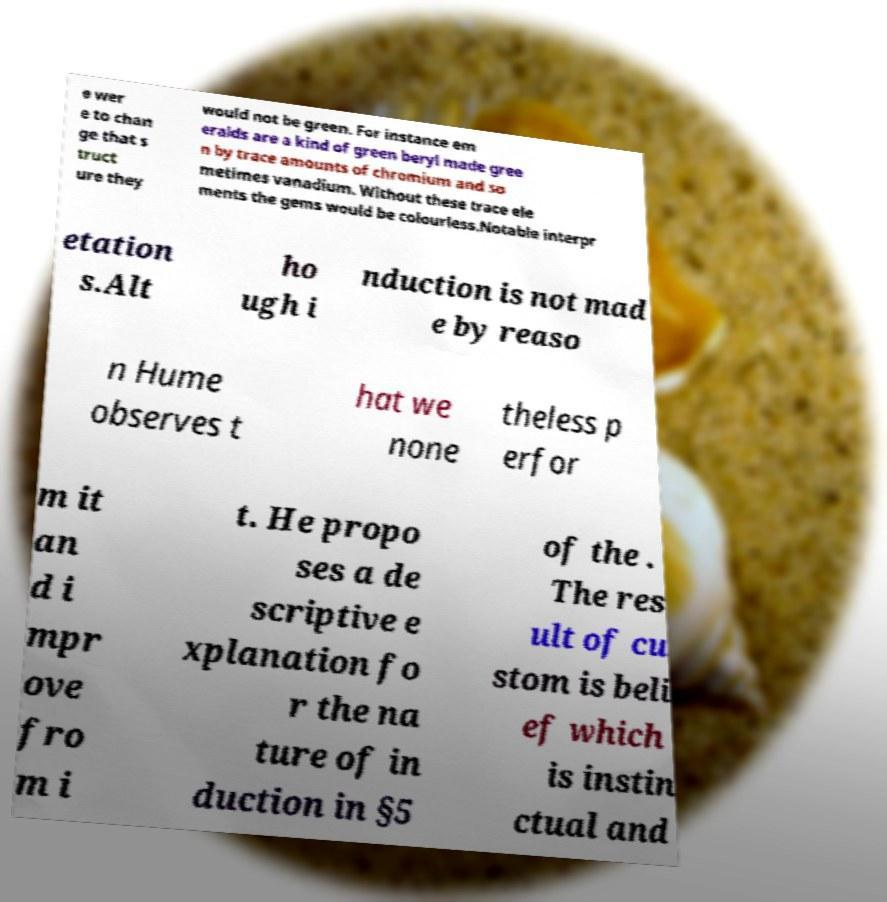There's text embedded in this image that I need extracted. Can you transcribe it verbatim? e wer e to chan ge that s truct ure they would not be green. For instance em eralds are a kind of green beryl made gree n by trace amounts of chromium and so metimes vanadium. Without these trace ele ments the gems would be colourless.Notable interpr etation s.Alt ho ugh i nduction is not mad e by reaso n Hume observes t hat we none theless p erfor m it an d i mpr ove fro m i t. He propo ses a de scriptive e xplanation fo r the na ture of in duction in §5 of the . The res ult of cu stom is beli ef which is instin ctual and 